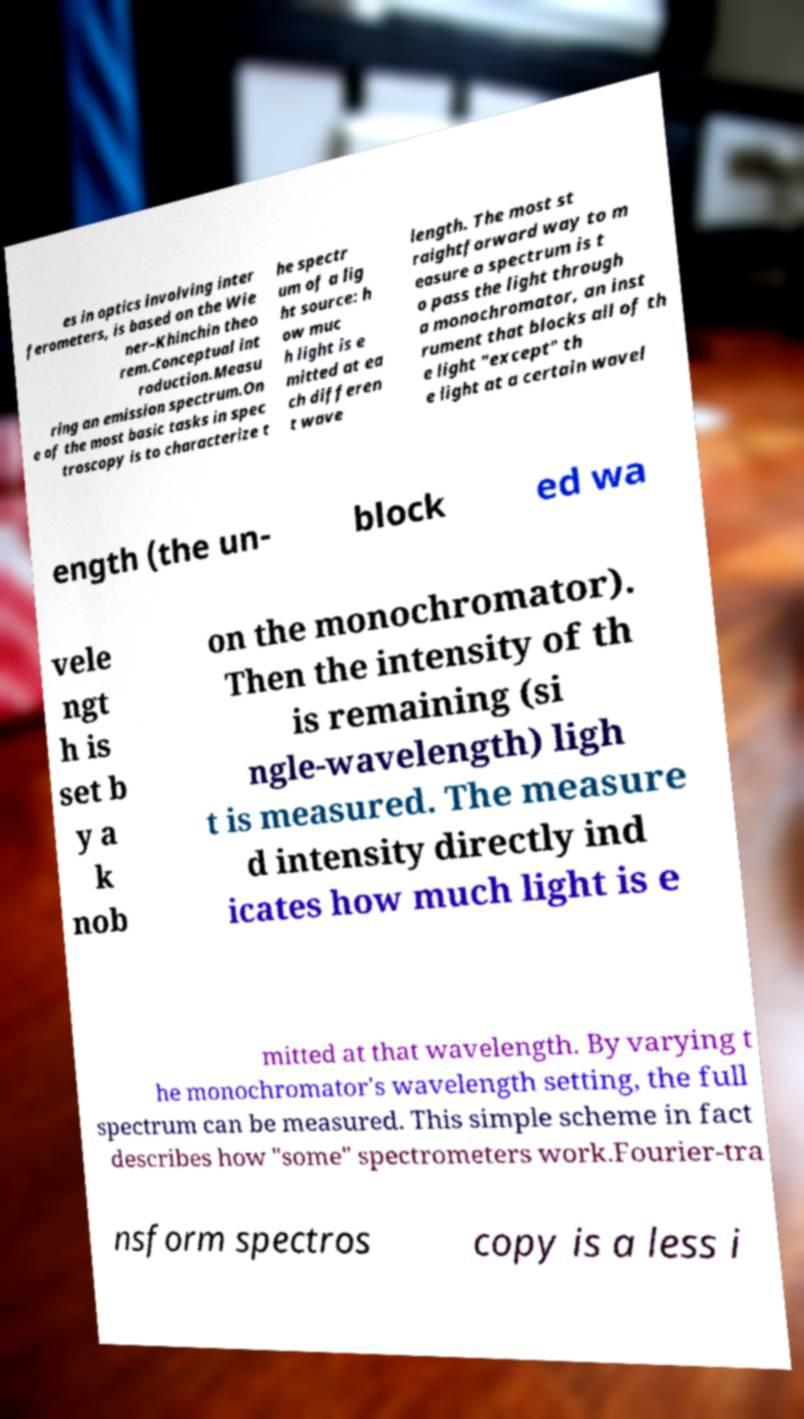There's text embedded in this image that I need extracted. Can you transcribe it verbatim? es in optics involving inter ferometers, is based on the Wie ner–Khinchin theo rem.Conceptual int roduction.Measu ring an emission spectrum.On e of the most basic tasks in spec troscopy is to characterize t he spectr um of a lig ht source: h ow muc h light is e mitted at ea ch differen t wave length. The most st raightforward way to m easure a spectrum is t o pass the light through a monochromator, an inst rument that blocks all of th e light "except" th e light at a certain wavel ength (the un- block ed wa vele ngt h is set b y a k nob on the monochromator). Then the intensity of th is remaining (si ngle-wavelength) ligh t is measured. The measure d intensity directly ind icates how much light is e mitted at that wavelength. By varying t he monochromator's wavelength setting, the full spectrum can be measured. This simple scheme in fact describes how "some" spectrometers work.Fourier-tra nsform spectros copy is a less i 